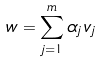Convert formula to latex. <formula><loc_0><loc_0><loc_500><loc_500>w = \sum _ { j = 1 } ^ { m } \alpha _ { j } \, v _ { j }</formula> 